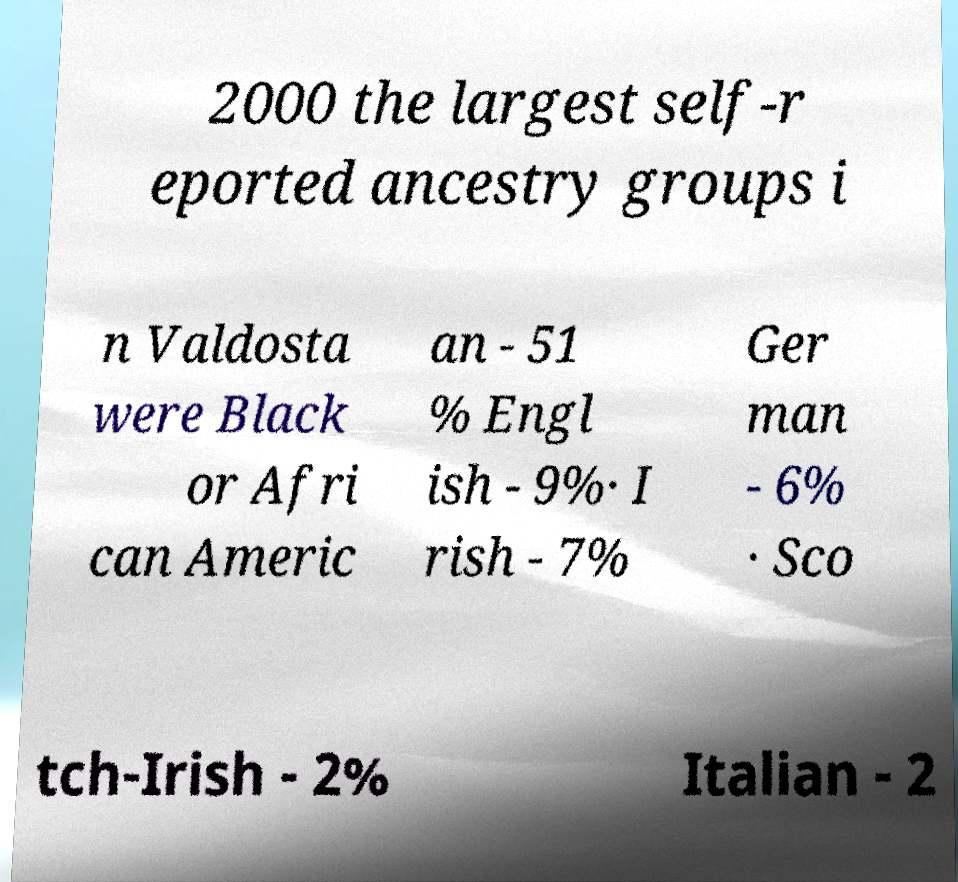For documentation purposes, I need the text within this image transcribed. Could you provide that? 2000 the largest self-r eported ancestry groups i n Valdosta were Black or Afri can Americ an - 51 % Engl ish - 9%· I rish - 7% Ger man - 6% · Sco tch-Irish - 2% Italian - 2 